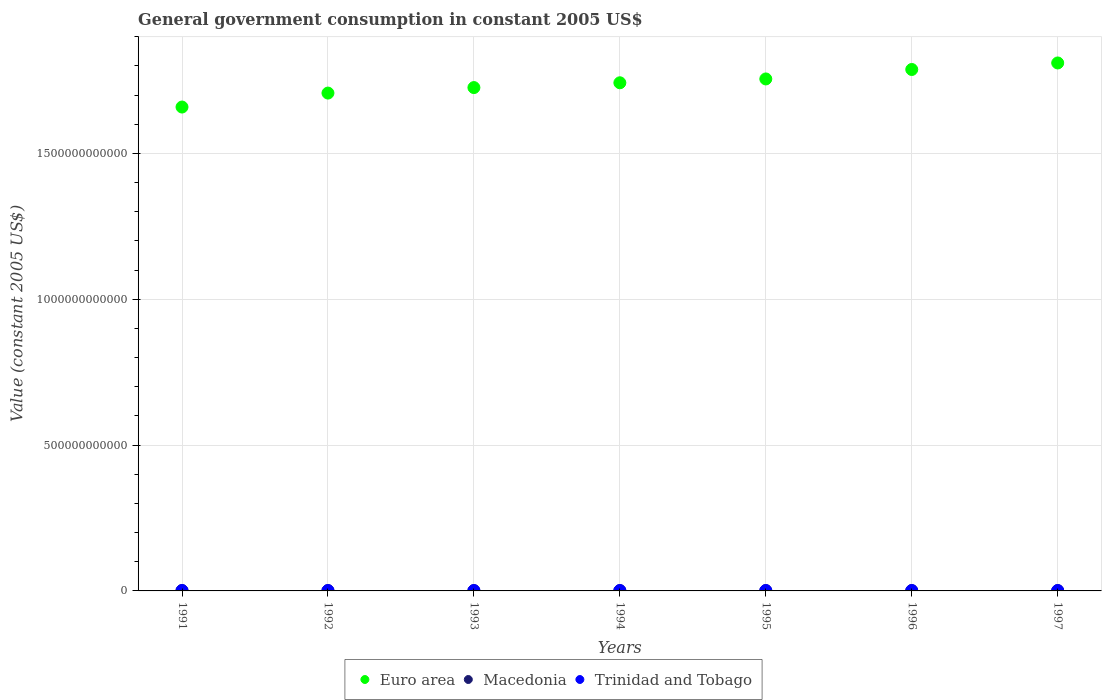How many different coloured dotlines are there?
Offer a terse response. 3. What is the government conusmption in Macedonia in 1995?
Ensure brevity in your answer.  9.99e+08. Across all years, what is the maximum government conusmption in Euro area?
Provide a succinct answer. 1.81e+12. Across all years, what is the minimum government conusmption in Macedonia?
Give a very brief answer. 9.45e+08. In which year was the government conusmption in Trinidad and Tobago minimum?
Ensure brevity in your answer.  1993. What is the total government conusmption in Euro area in the graph?
Offer a terse response. 1.22e+13. What is the difference between the government conusmption in Trinidad and Tobago in 1993 and that in 1996?
Your answer should be very brief. -5.13e+07. What is the difference between the government conusmption in Trinidad and Tobago in 1991 and the government conusmption in Euro area in 1992?
Your answer should be very brief. -1.71e+12. What is the average government conusmption in Trinidad and Tobago per year?
Provide a short and direct response. 1.26e+09. In the year 1996, what is the difference between the government conusmption in Macedonia and government conusmption in Trinidad and Tobago?
Your response must be concise. -2.74e+08. What is the ratio of the government conusmption in Trinidad and Tobago in 1994 to that in 1997?
Give a very brief answer. 1. What is the difference between the highest and the second highest government conusmption in Euro area?
Your answer should be compact. 2.24e+1. What is the difference between the highest and the lowest government conusmption in Trinidad and Tobago?
Give a very brief answer. 5.92e+07. Is it the case that in every year, the sum of the government conusmption in Macedonia and government conusmption in Euro area  is greater than the government conusmption in Trinidad and Tobago?
Provide a succinct answer. Yes. Does the government conusmption in Trinidad and Tobago monotonically increase over the years?
Offer a terse response. No. Is the government conusmption in Macedonia strictly greater than the government conusmption in Euro area over the years?
Provide a short and direct response. No. What is the difference between two consecutive major ticks on the Y-axis?
Your answer should be very brief. 5.00e+11. Does the graph contain grids?
Give a very brief answer. Yes. How are the legend labels stacked?
Give a very brief answer. Horizontal. What is the title of the graph?
Your answer should be compact. General government consumption in constant 2005 US$. What is the label or title of the X-axis?
Provide a succinct answer. Years. What is the label or title of the Y-axis?
Provide a succinct answer. Value (constant 2005 US$). What is the Value (constant 2005 US$) in Euro area in 1991?
Your answer should be compact. 1.66e+12. What is the Value (constant 2005 US$) in Macedonia in 1991?
Offer a terse response. 1.11e+09. What is the Value (constant 2005 US$) of Trinidad and Tobago in 1991?
Keep it short and to the point. 1.28e+09. What is the Value (constant 2005 US$) of Euro area in 1992?
Offer a terse response. 1.71e+12. What is the Value (constant 2005 US$) of Macedonia in 1992?
Ensure brevity in your answer.  9.95e+08. What is the Value (constant 2005 US$) in Trinidad and Tobago in 1992?
Offer a very short reply. 1.24e+09. What is the Value (constant 2005 US$) of Euro area in 1993?
Offer a terse response. 1.73e+12. What is the Value (constant 2005 US$) of Macedonia in 1993?
Your answer should be very brief. 9.56e+08. What is the Value (constant 2005 US$) of Trinidad and Tobago in 1993?
Give a very brief answer. 1.22e+09. What is the Value (constant 2005 US$) of Euro area in 1994?
Provide a short and direct response. 1.74e+12. What is the Value (constant 2005 US$) of Macedonia in 1994?
Your response must be concise. 9.45e+08. What is the Value (constant 2005 US$) of Trinidad and Tobago in 1994?
Provide a short and direct response. 1.27e+09. What is the Value (constant 2005 US$) in Euro area in 1995?
Your answer should be compact. 1.76e+12. What is the Value (constant 2005 US$) of Macedonia in 1995?
Offer a very short reply. 9.99e+08. What is the Value (constant 2005 US$) of Trinidad and Tobago in 1995?
Offer a very short reply. 1.24e+09. What is the Value (constant 2005 US$) in Euro area in 1996?
Offer a very short reply. 1.79e+12. What is the Value (constant 2005 US$) of Macedonia in 1996?
Your response must be concise. 1.00e+09. What is the Value (constant 2005 US$) in Trinidad and Tobago in 1996?
Give a very brief answer. 1.28e+09. What is the Value (constant 2005 US$) of Euro area in 1997?
Provide a short and direct response. 1.81e+12. What is the Value (constant 2005 US$) in Macedonia in 1997?
Your response must be concise. 9.77e+08. What is the Value (constant 2005 US$) in Trinidad and Tobago in 1997?
Provide a short and direct response. 1.27e+09. Across all years, what is the maximum Value (constant 2005 US$) in Euro area?
Your answer should be very brief. 1.81e+12. Across all years, what is the maximum Value (constant 2005 US$) in Macedonia?
Your response must be concise. 1.11e+09. Across all years, what is the maximum Value (constant 2005 US$) in Trinidad and Tobago?
Keep it short and to the point. 1.28e+09. Across all years, what is the minimum Value (constant 2005 US$) in Euro area?
Offer a terse response. 1.66e+12. Across all years, what is the minimum Value (constant 2005 US$) of Macedonia?
Your answer should be compact. 9.45e+08. Across all years, what is the minimum Value (constant 2005 US$) of Trinidad and Tobago?
Make the answer very short. 1.22e+09. What is the total Value (constant 2005 US$) in Euro area in the graph?
Offer a terse response. 1.22e+13. What is the total Value (constant 2005 US$) in Macedonia in the graph?
Your response must be concise. 6.99e+09. What is the total Value (constant 2005 US$) of Trinidad and Tobago in the graph?
Offer a terse response. 8.81e+09. What is the difference between the Value (constant 2005 US$) of Euro area in 1991 and that in 1992?
Your answer should be very brief. -4.79e+1. What is the difference between the Value (constant 2005 US$) of Macedonia in 1991 and that in 1992?
Your answer should be compact. 1.18e+08. What is the difference between the Value (constant 2005 US$) of Trinidad and Tobago in 1991 and that in 1992?
Keep it short and to the point. 4.63e+07. What is the difference between the Value (constant 2005 US$) in Euro area in 1991 and that in 1993?
Give a very brief answer. -6.67e+1. What is the difference between the Value (constant 2005 US$) of Macedonia in 1991 and that in 1993?
Give a very brief answer. 1.56e+08. What is the difference between the Value (constant 2005 US$) of Trinidad and Tobago in 1991 and that in 1993?
Offer a very short reply. 5.92e+07. What is the difference between the Value (constant 2005 US$) of Euro area in 1991 and that in 1994?
Your response must be concise. -8.32e+1. What is the difference between the Value (constant 2005 US$) of Macedonia in 1991 and that in 1994?
Offer a terse response. 1.67e+08. What is the difference between the Value (constant 2005 US$) of Trinidad and Tobago in 1991 and that in 1994?
Your answer should be compact. 1.02e+07. What is the difference between the Value (constant 2005 US$) of Euro area in 1991 and that in 1995?
Provide a succinct answer. -9.63e+1. What is the difference between the Value (constant 2005 US$) in Macedonia in 1991 and that in 1995?
Offer a very short reply. 1.13e+08. What is the difference between the Value (constant 2005 US$) of Trinidad and Tobago in 1991 and that in 1995?
Your answer should be compact. 4.08e+07. What is the difference between the Value (constant 2005 US$) in Euro area in 1991 and that in 1996?
Give a very brief answer. -1.29e+11. What is the difference between the Value (constant 2005 US$) of Macedonia in 1991 and that in 1996?
Offer a very short reply. 1.12e+08. What is the difference between the Value (constant 2005 US$) in Trinidad and Tobago in 1991 and that in 1996?
Make the answer very short. 7.81e+06. What is the difference between the Value (constant 2005 US$) of Euro area in 1991 and that in 1997?
Make the answer very short. -1.51e+11. What is the difference between the Value (constant 2005 US$) in Macedonia in 1991 and that in 1997?
Offer a very short reply. 1.36e+08. What is the difference between the Value (constant 2005 US$) in Trinidad and Tobago in 1991 and that in 1997?
Provide a short and direct response. 9.76e+06. What is the difference between the Value (constant 2005 US$) of Euro area in 1992 and that in 1993?
Offer a terse response. -1.89e+1. What is the difference between the Value (constant 2005 US$) in Macedonia in 1992 and that in 1993?
Offer a terse response. 3.87e+07. What is the difference between the Value (constant 2005 US$) in Trinidad and Tobago in 1992 and that in 1993?
Provide a short and direct response. 1.29e+07. What is the difference between the Value (constant 2005 US$) in Euro area in 1992 and that in 1994?
Ensure brevity in your answer.  -3.53e+1. What is the difference between the Value (constant 2005 US$) of Macedonia in 1992 and that in 1994?
Ensure brevity in your answer.  4.96e+07. What is the difference between the Value (constant 2005 US$) of Trinidad and Tobago in 1992 and that in 1994?
Provide a succinct answer. -3.61e+07. What is the difference between the Value (constant 2005 US$) in Euro area in 1992 and that in 1995?
Your answer should be compact. -4.85e+1. What is the difference between the Value (constant 2005 US$) in Macedonia in 1992 and that in 1995?
Provide a succinct answer. -4.35e+06. What is the difference between the Value (constant 2005 US$) of Trinidad and Tobago in 1992 and that in 1995?
Your answer should be compact. -5.47e+06. What is the difference between the Value (constant 2005 US$) of Euro area in 1992 and that in 1996?
Give a very brief answer. -8.09e+1. What is the difference between the Value (constant 2005 US$) in Macedonia in 1992 and that in 1996?
Your answer should be compact. -6.06e+06. What is the difference between the Value (constant 2005 US$) in Trinidad and Tobago in 1992 and that in 1996?
Keep it short and to the point. -3.85e+07. What is the difference between the Value (constant 2005 US$) of Euro area in 1992 and that in 1997?
Your answer should be compact. -1.03e+11. What is the difference between the Value (constant 2005 US$) of Macedonia in 1992 and that in 1997?
Offer a terse response. 1.80e+07. What is the difference between the Value (constant 2005 US$) of Trinidad and Tobago in 1992 and that in 1997?
Provide a short and direct response. -3.65e+07. What is the difference between the Value (constant 2005 US$) in Euro area in 1993 and that in 1994?
Offer a very short reply. -1.64e+1. What is the difference between the Value (constant 2005 US$) in Macedonia in 1993 and that in 1994?
Ensure brevity in your answer.  1.09e+07. What is the difference between the Value (constant 2005 US$) in Trinidad and Tobago in 1993 and that in 1994?
Your answer should be very brief. -4.90e+07. What is the difference between the Value (constant 2005 US$) of Euro area in 1993 and that in 1995?
Offer a very short reply. -2.96e+1. What is the difference between the Value (constant 2005 US$) in Macedonia in 1993 and that in 1995?
Offer a terse response. -4.30e+07. What is the difference between the Value (constant 2005 US$) in Trinidad and Tobago in 1993 and that in 1995?
Give a very brief answer. -1.84e+07. What is the difference between the Value (constant 2005 US$) in Euro area in 1993 and that in 1996?
Your answer should be compact. -6.20e+1. What is the difference between the Value (constant 2005 US$) in Macedonia in 1993 and that in 1996?
Your answer should be very brief. -4.47e+07. What is the difference between the Value (constant 2005 US$) in Trinidad and Tobago in 1993 and that in 1996?
Give a very brief answer. -5.13e+07. What is the difference between the Value (constant 2005 US$) of Euro area in 1993 and that in 1997?
Your response must be concise. -8.44e+1. What is the difference between the Value (constant 2005 US$) of Macedonia in 1993 and that in 1997?
Provide a short and direct response. -2.07e+07. What is the difference between the Value (constant 2005 US$) of Trinidad and Tobago in 1993 and that in 1997?
Ensure brevity in your answer.  -4.94e+07. What is the difference between the Value (constant 2005 US$) of Euro area in 1994 and that in 1995?
Offer a very short reply. -1.32e+1. What is the difference between the Value (constant 2005 US$) of Macedonia in 1994 and that in 1995?
Make the answer very short. -5.40e+07. What is the difference between the Value (constant 2005 US$) of Trinidad and Tobago in 1994 and that in 1995?
Offer a terse response. 3.06e+07. What is the difference between the Value (constant 2005 US$) of Euro area in 1994 and that in 1996?
Your response must be concise. -4.56e+1. What is the difference between the Value (constant 2005 US$) of Macedonia in 1994 and that in 1996?
Provide a succinct answer. -5.57e+07. What is the difference between the Value (constant 2005 US$) in Trinidad and Tobago in 1994 and that in 1996?
Provide a short and direct response. -2.34e+06. What is the difference between the Value (constant 2005 US$) in Euro area in 1994 and that in 1997?
Offer a very short reply. -6.79e+1. What is the difference between the Value (constant 2005 US$) in Macedonia in 1994 and that in 1997?
Your response must be concise. -3.16e+07. What is the difference between the Value (constant 2005 US$) of Trinidad and Tobago in 1994 and that in 1997?
Your response must be concise. -3.90e+05. What is the difference between the Value (constant 2005 US$) of Euro area in 1995 and that in 1996?
Provide a succinct answer. -3.24e+1. What is the difference between the Value (constant 2005 US$) of Macedonia in 1995 and that in 1996?
Your answer should be compact. -1.71e+06. What is the difference between the Value (constant 2005 US$) of Trinidad and Tobago in 1995 and that in 1996?
Keep it short and to the point. -3.30e+07. What is the difference between the Value (constant 2005 US$) of Euro area in 1995 and that in 1997?
Your answer should be compact. -5.48e+1. What is the difference between the Value (constant 2005 US$) of Macedonia in 1995 and that in 1997?
Offer a very short reply. 2.23e+07. What is the difference between the Value (constant 2005 US$) of Trinidad and Tobago in 1995 and that in 1997?
Your answer should be very brief. -3.10e+07. What is the difference between the Value (constant 2005 US$) of Euro area in 1996 and that in 1997?
Offer a very short reply. -2.24e+1. What is the difference between the Value (constant 2005 US$) of Macedonia in 1996 and that in 1997?
Ensure brevity in your answer.  2.40e+07. What is the difference between the Value (constant 2005 US$) in Trinidad and Tobago in 1996 and that in 1997?
Provide a short and direct response. 1.95e+06. What is the difference between the Value (constant 2005 US$) in Euro area in 1991 and the Value (constant 2005 US$) in Macedonia in 1992?
Ensure brevity in your answer.  1.66e+12. What is the difference between the Value (constant 2005 US$) in Euro area in 1991 and the Value (constant 2005 US$) in Trinidad and Tobago in 1992?
Keep it short and to the point. 1.66e+12. What is the difference between the Value (constant 2005 US$) of Macedonia in 1991 and the Value (constant 2005 US$) of Trinidad and Tobago in 1992?
Make the answer very short. -1.24e+08. What is the difference between the Value (constant 2005 US$) of Euro area in 1991 and the Value (constant 2005 US$) of Macedonia in 1993?
Your answer should be very brief. 1.66e+12. What is the difference between the Value (constant 2005 US$) of Euro area in 1991 and the Value (constant 2005 US$) of Trinidad and Tobago in 1993?
Ensure brevity in your answer.  1.66e+12. What is the difference between the Value (constant 2005 US$) in Macedonia in 1991 and the Value (constant 2005 US$) in Trinidad and Tobago in 1993?
Your response must be concise. -1.11e+08. What is the difference between the Value (constant 2005 US$) in Euro area in 1991 and the Value (constant 2005 US$) in Macedonia in 1994?
Keep it short and to the point. 1.66e+12. What is the difference between the Value (constant 2005 US$) in Euro area in 1991 and the Value (constant 2005 US$) in Trinidad and Tobago in 1994?
Provide a short and direct response. 1.66e+12. What is the difference between the Value (constant 2005 US$) of Macedonia in 1991 and the Value (constant 2005 US$) of Trinidad and Tobago in 1994?
Make the answer very short. -1.60e+08. What is the difference between the Value (constant 2005 US$) of Euro area in 1991 and the Value (constant 2005 US$) of Macedonia in 1995?
Offer a terse response. 1.66e+12. What is the difference between the Value (constant 2005 US$) in Euro area in 1991 and the Value (constant 2005 US$) in Trinidad and Tobago in 1995?
Offer a very short reply. 1.66e+12. What is the difference between the Value (constant 2005 US$) in Macedonia in 1991 and the Value (constant 2005 US$) in Trinidad and Tobago in 1995?
Ensure brevity in your answer.  -1.30e+08. What is the difference between the Value (constant 2005 US$) in Euro area in 1991 and the Value (constant 2005 US$) in Macedonia in 1996?
Give a very brief answer. 1.66e+12. What is the difference between the Value (constant 2005 US$) in Euro area in 1991 and the Value (constant 2005 US$) in Trinidad and Tobago in 1996?
Offer a very short reply. 1.66e+12. What is the difference between the Value (constant 2005 US$) in Macedonia in 1991 and the Value (constant 2005 US$) in Trinidad and Tobago in 1996?
Offer a very short reply. -1.63e+08. What is the difference between the Value (constant 2005 US$) in Euro area in 1991 and the Value (constant 2005 US$) in Macedonia in 1997?
Give a very brief answer. 1.66e+12. What is the difference between the Value (constant 2005 US$) of Euro area in 1991 and the Value (constant 2005 US$) of Trinidad and Tobago in 1997?
Keep it short and to the point. 1.66e+12. What is the difference between the Value (constant 2005 US$) of Macedonia in 1991 and the Value (constant 2005 US$) of Trinidad and Tobago in 1997?
Your answer should be compact. -1.61e+08. What is the difference between the Value (constant 2005 US$) in Euro area in 1992 and the Value (constant 2005 US$) in Macedonia in 1993?
Keep it short and to the point. 1.71e+12. What is the difference between the Value (constant 2005 US$) of Euro area in 1992 and the Value (constant 2005 US$) of Trinidad and Tobago in 1993?
Ensure brevity in your answer.  1.71e+12. What is the difference between the Value (constant 2005 US$) of Macedonia in 1992 and the Value (constant 2005 US$) of Trinidad and Tobago in 1993?
Offer a terse response. -2.29e+08. What is the difference between the Value (constant 2005 US$) in Euro area in 1992 and the Value (constant 2005 US$) in Macedonia in 1994?
Make the answer very short. 1.71e+12. What is the difference between the Value (constant 2005 US$) in Euro area in 1992 and the Value (constant 2005 US$) in Trinidad and Tobago in 1994?
Provide a short and direct response. 1.71e+12. What is the difference between the Value (constant 2005 US$) of Macedonia in 1992 and the Value (constant 2005 US$) of Trinidad and Tobago in 1994?
Ensure brevity in your answer.  -2.78e+08. What is the difference between the Value (constant 2005 US$) in Euro area in 1992 and the Value (constant 2005 US$) in Macedonia in 1995?
Provide a succinct answer. 1.71e+12. What is the difference between the Value (constant 2005 US$) in Euro area in 1992 and the Value (constant 2005 US$) in Trinidad and Tobago in 1995?
Your answer should be compact. 1.71e+12. What is the difference between the Value (constant 2005 US$) of Macedonia in 1992 and the Value (constant 2005 US$) of Trinidad and Tobago in 1995?
Your answer should be compact. -2.48e+08. What is the difference between the Value (constant 2005 US$) in Euro area in 1992 and the Value (constant 2005 US$) in Macedonia in 1996?
Ensure brevity in your answer.  1.71e+12. What is the difference between the Value (constant 2005 US$) in Euro area in 1992 and the Value (constant 2005 US$) in Trinidad and Tobago in 1996?
Keep it short and to the point. 1.71e+12. What is the difference between the Value (constant 2005 US$) of Macedonia in 1992 and the Value (constant 2005 US$) of Trinidad and Tobago in 1996?
Your answer should be very brief. -2.81e+08. What is the difference between the Value (constant 2005 US$) in Euro area in 1992 and the Value (constant 2005 US$) in Macedonia in 1997?
Make the answer very short. 1.71e+12. What is the difference between the Value (constant 2005 US$) in Euro area in 1992 and the Value (constant 2005 US$) in Trinidad and Tobago in 1997?
Your response must be concise. 1.71e+12. What is the difference between the Value (constant 2005 US$) in Macedonia in 1992 and the Value (constant 2005 US$) in Trinidad and Tobago in 1997?
Your answer should be very brief. -2.79e+08. What is the difference between the Value (constant 2005 US$) in Euro area in 1993 and the Value (constant 2005 US$) in Macedonia in 1994?
Keep it short and to the point. 1.72e+12. What is the difference between the Value (constant 2005 US$) in Euro area in 1993 and the Value (constant 2005 US$) in Trinidad and Tobago in 1994?
Keep it short and to the point. 1.72e+12. What is the difference between the Value (constant 2005 US$) in Macedonia in 1993 and the Value (constant 2005 US$) in Trinidad and Tobago in 1994?
Your answer should be compact. -3.17e+08. What is the difference between the Value (constant 2005 US$) of Euro area in 1993 and the Value (constant 2005 US$) of Macedonia in 1995?
Your answer should be very brief. 1.72e+12. What is the difference between the Value (constant 2005 US$) in Euro area in 1993 and the Value (constant 2005 US$) in Trinidad and Tobago in 1995?
Your response must be concise. 1.72e+12. What is the difference between the Value (constant 2005 US$) of Macedonia in 1993 and the Value (constant 2005 US$) of Trinidad and Tobago in 1995?
Ensure brevity in your answer.  -2.86e+08. What is the difference between the Value (constant 2005 US$) of Euro area in 1993 and the Value (constant 2005 US$) of Macedonia in 1996?
Your answer should be very brief. 1.72e+12. What is the difference between the Value (constant 2005 US$) in Euro area in 1993 and the Value (constant 2005 US$) in Trinidad and Tobago in 1996?
Your response must be concise. 1.72e+12. What is the difference between the Value (constant 2005 US$) of Macedonia in 1993 and the Value (constant 2005 US$) of Trinidad and Tobago in 1996?
Offer a terse response. -3.19e+08. What is the difference between the Value (constant 2005 US$) of Euro area in 1993 and the Value (constant 2005 US$) of Macedonia in 1997?
Provide a short and direct response. 1.72e+12. What is the difference between the Value (constant 2005 US$) in Euro area in 1993 and the Value (constant 2005 US$) in Trinidad and Tobago in 1997?
Your answer should be very brief. 1.72e+12. What is the difference between the Value (constant 2005 US$) of Macedonia in 1993 and the Value (constant 2005 US$) of Trinidad and Tobago in 1997?
Provide a succinct answer. -3.17e+08. What is the difference between the Value (constant 2005 US$) in Euro area in 1994 and the Value (constant 2005 US$) in Macedonia in 1995?
Make the answer very short. 1.74e+12. What is the difference between the Value (constant 2005 US$) of Euro area in 1994 and the Value (constant 2005 US$) of Trinidad and Tobago in 1995?
Give a very brief answer. 1.74e+12. What is the difference between the Value (constant 2005 US$) in Macedonia in 1994 and the Value (constant 2005 US$) in Trinidad and Tobago in 1995?
Ensure brevity in your answer.  -2.97e+08. What is the difference between the Value (constant 2005 US$) in Euro area in 1994 and the Value (constant 2005 US$) in Macedonia in 1996?
Keep it short and to the point. 1.74e+12. What is the difference between the Value (constant 2005 US$) of Euro area in 1994 and the Value (constant 2005 US$) of Trinidad and Tobago in 1996?
Ensure brevity in your answer.  1.74e+12. What is the difference between the Value (constant 2005 US$) in Macedonia in 1994 and the Value (constant 2005 US$) in Trinidad and Tobago in 1996?
Your answer should be compact. -3.30e+08. What is the difference between the Value (constant 2005 US$) of Euro area in 1994 and the Value (constant 2005 US$) of Macedonia in 1997?
Keep it short and to the point. 1.74e+12. What is the difference between the Value (constant 2005 US$) of Euro area in 1994 and the Value (constant 2005 US$) of Trinidad and Tobago in 1997?
Your answer should be compact. 1.74e+12. What is the difference between the Value (constant 2005 US$) of Macedonia in 1994 and the Value (constant 2005 US$) of Trinidad and Tobago in 1997?
Your answer should be compact. -3.28e+08. What is the difference between the Value (constant 2005 US$) of Euro area in 1995 and the Value (constant 2005 US$) of Macedonia in 1996?
Keep it short and to the point. 1.75e+12. What is the difference between the Value (constant 2005 US$) of Euro area in 1995 and the Value (constant 2005 US$) of Trinidad and Tobago in 1996?
Offer a terse response. 1.75e+12. What is the difference between the Value (constant 2005 US$) of Macedonia in 1995 and the Value (constant 2005 US$) of Trinidad and Tobago in 1996?
Keep it short and to the point. -2.76e+08. What is the difference between the Value (constant 2005 US$) of Euro area in 1995 and the Value (constant 2005 US$) of Macedonia in 1997?
Your response must be concise. 1.75e+12. What is the difference between the Value (constant 2005 US$) in Euro area in 1995 and the Value (constant 2005 US$) in Trinidad and Tobago in 1997?
Provide a succinct answer. 1.75e+12. What is the difference between the Value (constant 2005 US$) of Macedonia in 1995 and the Value (constant 2005 US$) of Trinidad and Tobago in 1997?
Make the answer very short. -2.74e+08. What is the difference between the Value (constant 2005 US$) in Euro area in 1996 and the Value (constant 2005 US$) in Macedonia in 1997?
Your response must be concise. 1.79e+12. What is the difference between the Value (constant 2005 US$) of Euro area in 1996 and the Value (constant 2005 US$) of Trinidad and Tobago in 1997?
Your response must be concise. 1.79e+12. What is the difference between the Value (constant 2005 US$) in Macedonia in 1996 and the Value (constant 2005 US$) in Trinidad and Tobago in 1997?
Offer a terse response. -2.72e+08. What is the average Value (constant 2005 US$) of Euro area per year?
Ensure brevity in your answer.  1.74e+12. What is the average Value (constant 2005 US$) of Macedonia per year?
Your answer should be compact. 9.98e+08. What is the average Value (constant 2005 US$) in Trinidad and Tobago per year?
Give a very brief answer. 1.26e+09. In the year 1991, what is the difference between the Value (constant 2005 US$) in Euro area and Value (constant 2005 US$) in Macedonia?
Offer a very short reply. 1.66e+12. In the year 1991, what is the difference between the Value (constant 2005 US$) in Euro area and Value (constant 2005 US$) in Trinidad and Tobago?
Your answer should be very brief. 1.66e+12. In the year 1991, what is the difference between the Value (constant 2005 US$) of Macedonia and Value (constant 2005 US$) of Trinidad and Tobago?
Your answer should be very brief. -1.71e+08. In the year 1992, what is the difference between the Value (constant 2005 US$) in Euro area and Value (constant 2005 US$) in Macedonia?
Provide a succinct answer. 1.71e+12. In the year 1992, what is the difference between the Value (constant 2005 US$) of Euro area and Value (constant 2005 US$) of Trinidad and Tobago?
Offer a very short reply. 1.71e+12. In the year 1992, what is the difference between the Value (constant 2005 US$) in Macedonia and Value (constant 2005 US$) in Trinidad and Tobago?
Keep it short and to the point. -2.42e+08. In the year 1993, what is the difference between the Value (constant 2005 US$) in Euro area and Value (constant 2005 US$) in Macedonia?
Give a very brief answer. 1.72e+12. In the year 1993, what is the difference between the Value (constant 2005 US$) in Euro area and Value (constant 2005 US$) in Trinidad and Tobago?
Keep it short and to the point. 1.72e+12. In the year 1993, what is the difference between the Value (constant 2005 US$) in Macedonia and Value (constant 2005 US$) in Trinidad and Tobago?
Provide a short and direct response. -2.68e+08. In the year 1994, what is the difference between the Value (constant 2005 US$) of Euro area and Value (constant 2005 US$) of Macedonia?
Offer a terse response. 1.74e+12. In the year 1994, what is the difference between the Value (constant 2005 US$) of Euro area and Value (constant 2005 US$) of Trinidad and Tobago?
Keep it short and to the point. 1.74e+12. In the year 1994, what is the difference between the Value (constant 2005 US$) in Macedonia and Value (constant 2005 US$) in Trinidad and Tobago?
Offer a very short reply. -3.28e+08. In the year 1995, what is the difference between the Value (constant 2005 US$) in Euro area and Value (constant 2005 US$) in Macedonia?
Provide a succinct answer. 1.75e+12. In the year 1995, what is the difference between the Value (constant 2005 US$) in Euro area and Value (constant 2005 US$) in Trinidad and Tobago?
Make the answer very short. 1.75e+12. In the year 1995, what is the difference between the Value (constant 2005 US$) in Macedonia and Value (constant 2005 US$) in Trinidad and Tobago?
Provide a short and direct response. -2.43e+08. In the year 1996, what is the difference between the Value (constant 2005 US$) of Euro area and Value (constant 2005 US$) of Macedonia?
Offer a very short reply. 1.79e+12. In the year 1996, what is the difference between the Value (constant 2005 US$) in Euro area and Value (constant 2005 US$) in Trinidad and Tobago?
Your answer should be very brief. 1.79e+12. In the year 1996, what is the difference between the Value (constant 2005 US$) in Macedonia and Value (constant 2005 US$) in Trinidad and Tobago?
Provide a short and direct response. -2.74e+08. In the year 1997, what is the difference between the Value (constant 2005 US$) of Euro area and Value (constant 2005 US$) of Macedonia?
Provide a succinct answer. 1.81e+12. In the year 1997, what is the difference between the Value (constant 2005 US$) in Euro area and Value (constant 2005 US$) in Trinidad and Tobago?
Give a very brief answer. 1.81e+12. In the year 1997, what is the difference between the Value (constant 2005 US$) in Macedonia and Value (constant 2005 US$) in Trinidad and Tobago?
Offer a very short reply. -2.97e+08. What is the ratio of the Value (constant 2005 US$) in Macedonia in 1991 to that in 1992?
Keep it short and to the point. 1.12. What is the ratio of the Value (constant 2005 US$) in Trinidad and Tobago in 1991 to that in 1992?
Offer a very short reply. 1.04. What is the ratio of the Value (constant 2005 US$) of Euro area in 1991 to that in 1993?
Offer a terse response. 0.96. What is the ratio of the Value (constant 2005 US$) in Macedonia in 1991 to that in 1993?
Offer a terse response. 1.16. What is the ratio of the Value (constant 2005 US$) in Trinidad and Tobago in 1991 to that in 1993?
Offer a terse response. 1.05. What is the ratio of the Value (constant 2005 US$) in Euro area in 1991 to that in 1994?
Your answer should be very brief. 0.95. What is the ratio of the Value (constant 2005 US$) of Macedonia in 1991 to that in 1994?
Give a very brief answer. 1.18. What is the ratio of the Value (constant 2005 US$) of Euro area in 1991 to that in 1995?
Provide a succinct answer. 0.95. What is the ratio of the Value (constant 2005 US$) of Macedonia in 1991 to that in 1995?
Offer a terse response. 1.11. What is the ratio of the Value (constant 2005 US$) in Trinidad and Tobago in 1991 to that in 1995?
Offer a very short reply. 1.03. What is the ratio of the Value (constant 2005 US$) of Euro area in 1991 to that in 1996?
Keep it short and to the point. 0.93. What is the ratio of the Value (constant 2005 US$) of Macedonia in 1991 to that in 1996?
Your response must be concise. 1.11. What is the ratio of the Value (constant 2005 US$) in Trinidad and Tobago in 1991 to that in 1996?
Your answer should be very brief. 1.01. What is the ratio of the Value (constant 2005 US$) of Euro area in 1991 to that in 1997?
Give a very brief answer. 0.92. What is the ratio of the Value (constant 2005 US$) of Macedonia in 1991 to that in 1997?
Give a very brief answer. 1.14. What is the ratio of the Value (constant 2005 US$) in Trinidad and Tobago in 1991 to that in 1997?
Provide a short and direct response. 1.01. What is the ratio of the Value (constant 2005 US$) in Euro area in 1992 to that in 1993?
Keep it short and to the point. 0.99. What is the ratio of the Value (constant 2005 US$) of Macedonia in 1992 to that in 1993?
Provide a succinct answer. 1.04. What is the ratio of the Value (constant 2005 US$) of Trinidad and Tobago in 1992 to that in 1993?
Offer a terse response. 1.01. What is the ratio of the Value (constant 2005 US$) of Euro area in 1992 to that in 1994?
Keep it short and to the point. 0.98. What is the ratio of the Value (constant 2005 US$) in Macedonia in 1992 to that in 1994?
Your answer should be compact. 1.05. What is the ratio of the Value (constant 2005 US$) in Trinidad and Tobago in 1992 to that in 1994?
Offer a terse response. 0.97. What is the ratio of the Value (constant 2005 US$) of Euro area in 1992 to that in 1995?
Offer a very short reply. 0.97. What is the ratio of the Value (constant 2005 US$) of Macedonia in 1992 to that in 1995?
Ensure brevity in your answer.  1. What is the ratio of the Value (constant 2005 US$) of Trinidad and Tobago in 1992 to that in 1995?
Ensure brevity in your answer.  1. What is the ratio of the Value (constant 2005 US$) of Euro area in 1992 to that in 1996?
Your answer should be compact. 0.95. What is the ratio of the Value (constant 2005 US$) in Macedonia in 1992 to that in 1996?
Your answer should be very brief. 0.99. What is the ratio of the Value (constant 2005 US$) of Trinidad and Tobago in 1992 to that in 1996?
Your response must be concise. 0.97. What is the ratio of the Value (constant 2005 US$) of Euro area in 1992 to that in 1997?
Give a very brief answer. 0.94. What is the ratio of the Value (constant 2005 US$) in Macedonia in 1992 to that in 1997?
Your answer should be very brief. 1.02. What is the ratio of the Value (constant 2005 US$) of Trinidad and Tobago in 1992 to that in 1997?
Provide a succinct answer. 0.97. What is the ratio of the Value (constant 2005 US$) of Euro area in 1993 to that in 1994?
Make the answer very short. 0.99. What is the ratio of the Value (constant 2005 US$) in Macedonia in 1993 to that in 1994?
Ensure brevity in your answer.  1.01. What is the ratio of the Value (constant 2005 US$) in Trinidad and Tobago in 1993 to that in 1994?
Your answer should be compact. 0.96. What is the ratio of the Value (constant 2005 US$) of Euro area in 1993 to that in 1995?
Your response must be concise. 0.98. What is the ratio of the Value (constant 2005 US$) in Trinidad and Tobago in 1993 to that in 1995?
Keep it short and to the point. 0.99. What is the ratio of the Value (constant 2005 US$) of Euro area in 1993 to that in 1996?
Provide a succinct answer. 0.97. What is the ratio of the Value (constant 2005 US$) of Macedonia in 1993 to that in 1996?
Your response must be concise. 0.96. What is the ratio of the Value (constant 2005 US$) of Trinidad and Tobago in 1993 to that in 1996?
Your answer should be very brief. 0.96. What is the ratio of the Value (constant 2005 US$) of Euro area in 1993 to that in 1997?
Provide a short and direct response. 0.95. What is the ratio of the Value (constant 2005 US$) in Macedonia in 1993 to that in 1997?
Your answer should be compact. 0.98. What is the ratio of the Value (constant 2005 US$) in Trinidad and Tobago in 1993 to that in 1997?
Offer a very short reply. 0.96. What is the ratio of the Value (constant 2005 US$) in Macedonia in 1994 to that in 1995?
Your answer should be compact. 0.95. What is the ratio of the Value (constant 2005 US$) of Trinidad and Tobago in 1994 to that in 1995?
Provide a succinct answer. 1.02. What is the ratio of the Value (constant 2005 US$) in Euro area in 1994 to that in 1996?
Offer a very short reply. 0.97. What is the ratio of the Value (constant 2005 US$) in Macedonia in 1994 to that in 1996?
Your answer should be compact. 0.94. What is the ratio of the Value (constant 2005 US$) in Trinidad and Tobago in 1994 to that in 1996?
Ensure brevity in your answer.  1. What is the ratio of the Value (constant 2005 US$) in Euro area in 1994 to that in 1997?
Offer a terse response. 0.96. What is the ratio of the Value (constant 2005 US$) in Macedonia in 1994 to that in 1997?
Offer a very short reply. 0.97. What is the ratio of the Value (constant 2005 US$) of Trinidad and Tobago in 1994 to that in 1997?
Ensure brevity in your answer.  1. What is the ratio of the Value (constant 2005 US$) of Euro area in 1995 to that in 1996?
Offer a terse response. 0.98. What is the ratio of the Value (constant 2005 US$) in Trinidad and Tobago in 1995 to that in 1996?
Your response must be concise. 0.97. What is the ratio of the Value (constant 2005 US$) in Euro area in 1995 to that in 1997?
Provide a short and direct response. 0.97. What is the ratio of the Value (constant 2005 US$) in Macedonia in 1995 to that in 1997?
Provide a succinct answer. 1.02. What is the ratio of the Value (constant 2005 US$) of Trinidad and Tobago in 1995 to that in 1997?
Provide a short and direct response. 0.98. What is the ratio of the Value (constant 2005 US$) of Euro area in 1996 to that in 1997?
Your answer should be compact. 0.99. What is the ratio of the Value (constant 2005 US$) in Macedonia in 1996 to that in 1997?
Provide a short and direct response. 1.02. What is the difference between the highest and the second highest Value (constant 2005 US$) in Euro area?
Ensure brevity in your answer.  2.24e+1. What is the difference between the highest and the second highest Value (constant 2005 US$) in Macedonia?
Provide a succinct answer. 1.12e+08. What is the difference between the highest and the second highest Value (constant 2005 US$) of Trinidad and Tobago?
Ensure brevity in your answer.  7.81e+06. What is the difference between the highest and the lowest Value (constant 2005 US$) in Euro area?
Your answer should be very brief. 1.51e+11. What is the difference between the highest and the lowest Value (constant 2005 US$) in Macedonia?
Provide a succinct answer. 1.67e+08. What is the difference between the highest and the lowest Value (constant 2005 US$) of Trinidad and Tobago?
Offer a very short reply. 5.92e+07. 